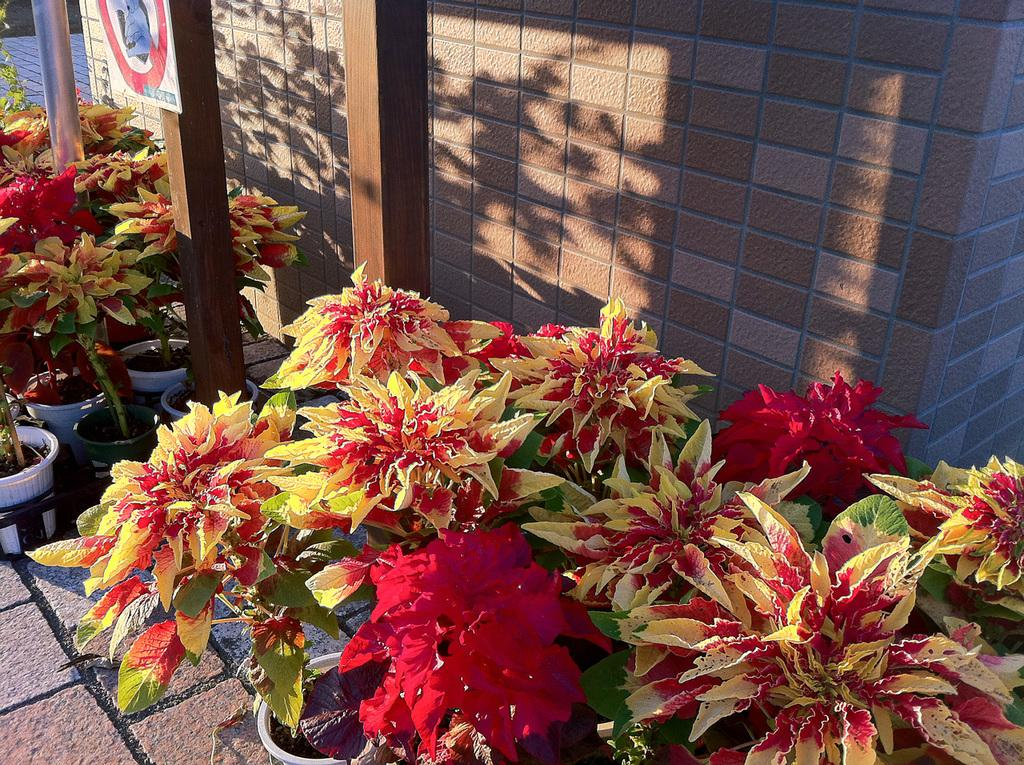What type of plants are in the image? There are house plants in the image. What can be seen in the background of the image? There is a wall and poles in the background of the image. What type of wire is being used to hold the loaf in the image? There is no wire or loaf present in the image. What type of relation can be seen between the plants and the wall in the image? There is no indication of a relation between the plants and the wall in the image; they are simply separate elements in the scene. 